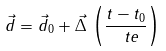<formula> <loc_0><loc_0><loc_500><loc_500>\vec { d } = \vec { d } _ { 0 } + \vec { \Delta } \, \left ( { \frac { t - t _ { 0 } } { \ t e } } \right )</formula> 